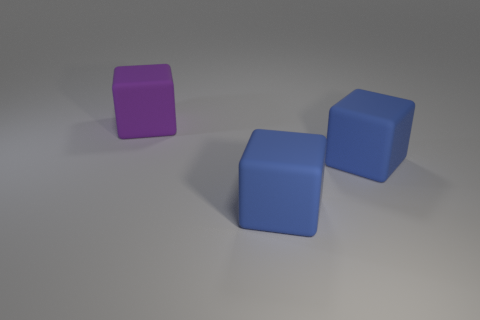Subtract all blue matte blocks. How many blocks are left? 1 Subtract all gray cylinders. How many blue cubes are left? 2 Add 1 blue rubber cubes. How many objects exist? 4 Subtract 1 cubes. How many cubes are left? 2 Subtract 1 purple blocks. How many objects are left? 2 Subtract all gray blocks. Subtract all yellow cylinders. How many blocks are left? 3 Subtract all large rubber blocks. Subtract all small red cylinders. How many objects are left? 0 Add 2 big purple cubes. How many big purple cubes are left? 3 Add 2 big blue objects. How many big blue objects exist? 4 